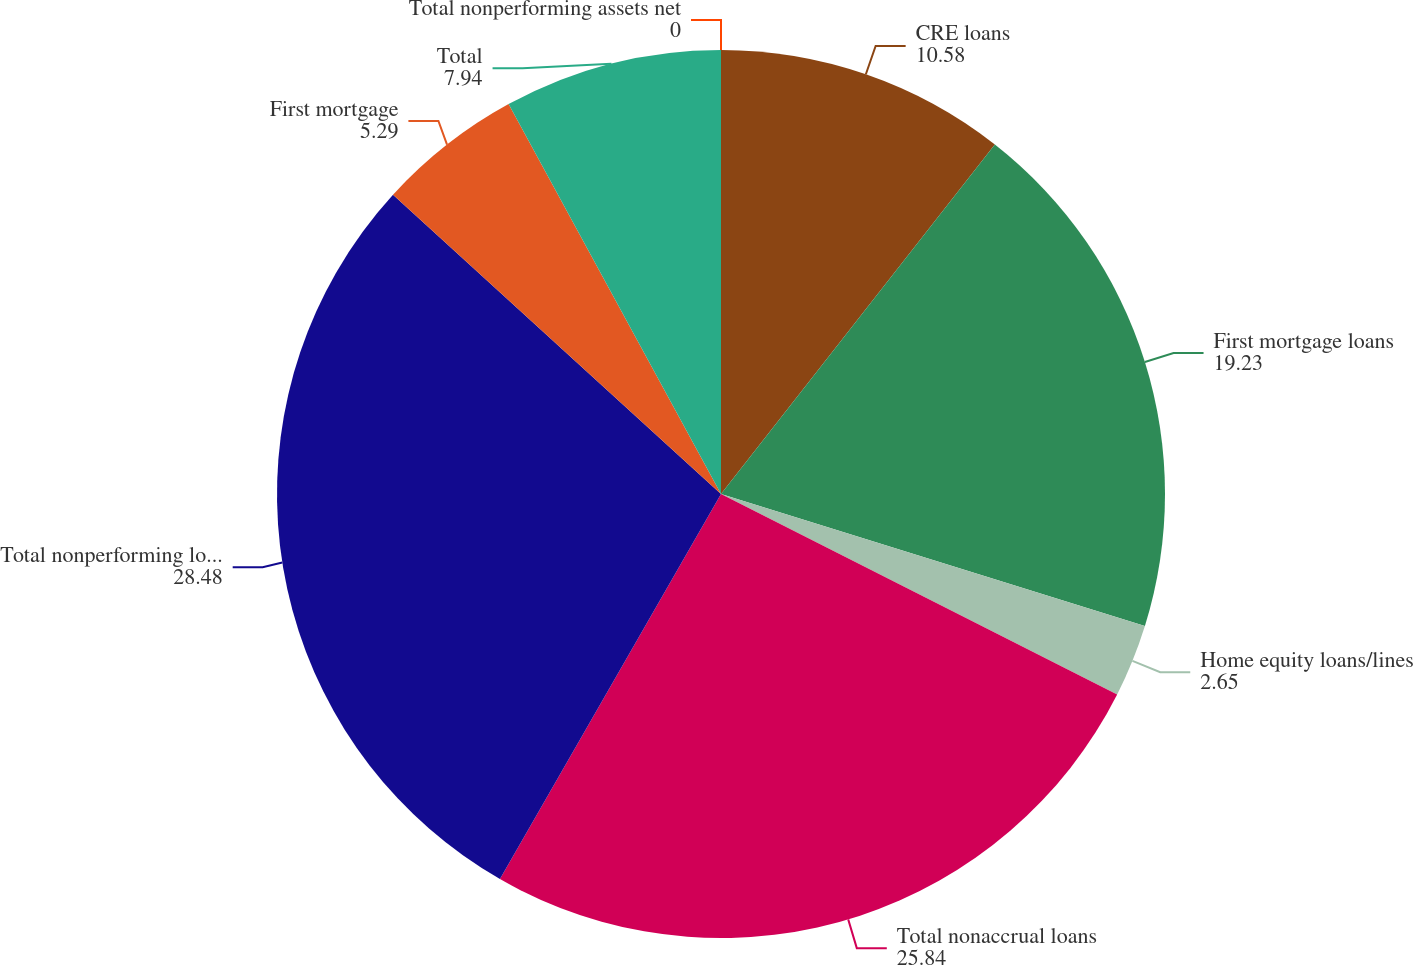Convert chart to OTSL. <chart><loc_0><loc_0><loc_500><loc_500><pie_chart><fcel>CRE loans<fcel>First mortgage loans<fcel>Home equity loans/lines<fcel>Total nonaccrual loans<fcel>Total nonperforming loans<fcel>First mortgage<fcel>Total<fcel>Total nonperforming assets net<nl><fcel>10.58%<fcel>19.23%<fcel>2.65%<fcel>25.84%<fcel>28.48%<fcel>5.29%<fcel>7.94%<fcel>0.0%<nl></chart> 